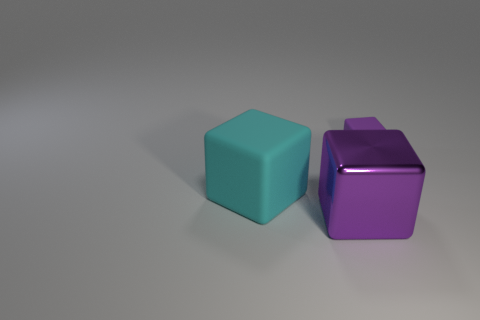Add 3 blue metal cylinders. How many objects exist? 6 Add 3 purple metal blocks. How many purple metal blocks are left? 4 Add 2 metal things. How many metal things exist? 3 Subtract 0 gray cylinders. How many objects are left? 3 Subtract all big things. Subtract all small cubes. How many objects are left? 0 